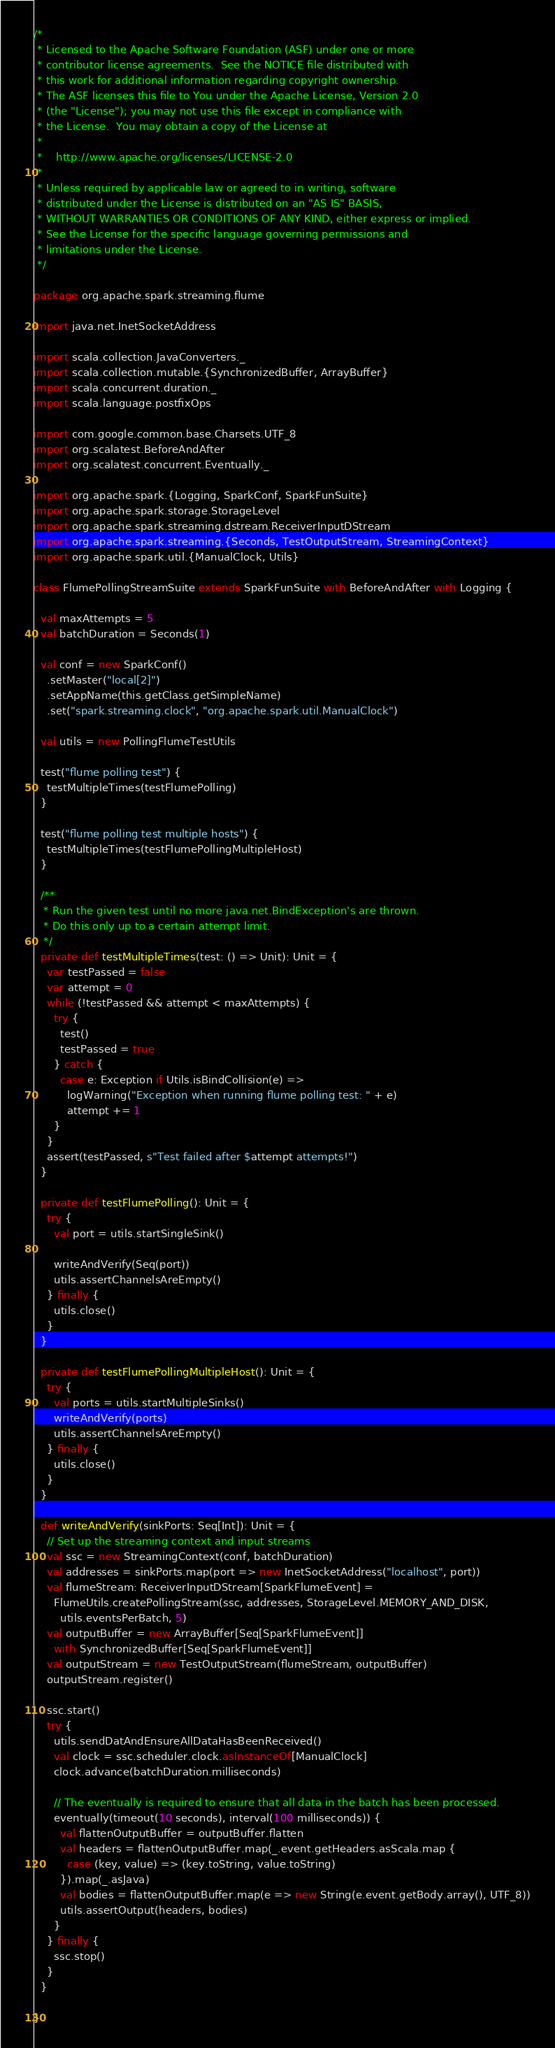<code> <loc_0><loc_0><loc_500><loc_500><_Scala_>/*
 * Licensed to the Apache Software Foundation (ASF) under one or more
 * contributor license agreements.  See the NOTICE file distributed with
 * this work for additional information regarding copyright ownership.
 * The ASF licenses this file to You under the Apache License, Version 2.0
 * (the "License"); you may not use this file except in compliance with
 * the License.  You may obtain a copy of the License at
 *
 *    http://www.apache.org/licenses/LICENSE-2.0
 *
 * Unless required by applicable law or agreed to in writing, software
 * distributed under the License is distributed on an "AS IS" BASIS,
 * WITHOUT WARRANTIES OR CONDITIONS OF ANY KIND, either express or implied.
 * See the License for the specific language governing permissions and
 * limitations under the License.
 */

package org.apache.spark.streaming.flume

import java.net.InetSocketAddress

import scala.collection.JavaConverters._
import scala.collection.mutable.{SynchronizedBuffer, ArrayBuffer}
import scala.concurrent.duration._
import scala.language.postfixOps

import com.google.common.base.Charsets.UTF_8
import org.scalatest.BeforeAndAfter
import org.scalatest.concurrent.Eventually._

import org.apache.spark.{Logging, SparkConf, SparkFunSuite}
import org.apache.spark.storage.StorageLevel
import org.apache.spark.streaming.dstream.ReceiverInputDStream
import org.apache.spark.streaming.{Seconds, TestOutputStream, StreamingContext}
import org.apache.spark.util.{ManualClock, Utils}

class FlumePollingStreamSuite extends SparkFunSuite with BeforeAndAfter with Logging {

  val maxAttempts = 5
  val batchDuration = Seconds(1)

  val conf = new SparkConf()
    .setMaster("local[2]")
    .setAppName(this.getClass.getSimpleName)
    .set("spark.streaming.clock", "org.apache.spark.util.ManualClock")

  val utils = new PollingFlumeTestUtils

  test("flume polling test") {
    testMultipleTimes(testFlumePolling)
  }

  test("flume polling test multiple hosts") {
    testMultipleTimes(testFlumePollingMultipleHost)
  }

  /**
   * Run the given test until no more java.net.BindException's are thrown.
   * Do this only up to a certain attempt limit.
   */
  private def testMultipleTimes(test: () => Unit): Unit = {
    var testPassed = false
    var attempt = 0
    while (!testPassed && attempt < maxAttempts) {
      try {
        test()
        testPassed = true
      } catch {
        case e: Exception if Utils.isBindCollision(e) =>
          logWarning("Exception when running flume polling test: " + e)
          attempt += 1
      }
    }
    assert(testPassed, s"Test failed after $attempt attempts!")
  }

  private def testFlumePolling(): Unit = {
    try {
      val port = utils.startSingleSink()

      writeAndVerify(Seq(port))
      utils.assertChannelsAreEmpty()
    } finally {
      utils.close()
    }
  }

  private def testFlumePollingMultipleHost(): Unit = {
    try {
      val ports = utils.startMultipleSinks()
      writeAndVerify(ports)
      utils.assertChannelsAreEmpty()
    } finally {
      utils.close()
    }
  }

  def writeAndVerify(sinkPorts: Seq[Int]): Unit = {
    // Set up the streaming context and input streams
    val ssc = new StreamingContext(conf, batchDuration)
    val addresses = sinkPorts.map(port => new InetSocketAddress("localhost", port))
    val flumeStream: ReceiverInputDStream[SparkFlumeEvent] =
      FlumeUtils.createPollingStream(ssc, addresses, StorageLevel.MEMORY_AND_DISK,
        utils.eventsPerBatch, 5)
    val outputBuffer = new ArrayBuffer[Seq[SparkFlumeEvent]]
      with SynchronizedBuffer[Seq[SparkFlumeEvent]]
    val outputStream = new TestOutputStream(flumeStream, outputBuffer)
    outputStream.register()

    ssc.start()
    try {
      utils.sendDatAndEnsureAllDataHasBeenReceived()
      val clock = ssc.scheduler.clock.asInstanceOf[ManualClock]
      clock.advance(batchDuration.milliseconds)

      // The eventually is required to ensure that all data in the batch has been processed.
      eventually(timeout(10 seconds), interval(100 milliseconds)) {
        val flattenOutputBuffer = outputBuffer.flatten
        val headers = flattenOutputBuffer.map(_.event.getHeaders.asScala.map {
          case (key, value) => (key.toString, value.toString)
        }).map(_.asJava)
        val bodies = flattenOutputBuffer.map(e => new String(e.event.getBody.array(), UTF_8))
        utils.assertOutput(headers, bodies)
      }
    } finally {
      ssc.stop()
    }
  }

}
</code> 